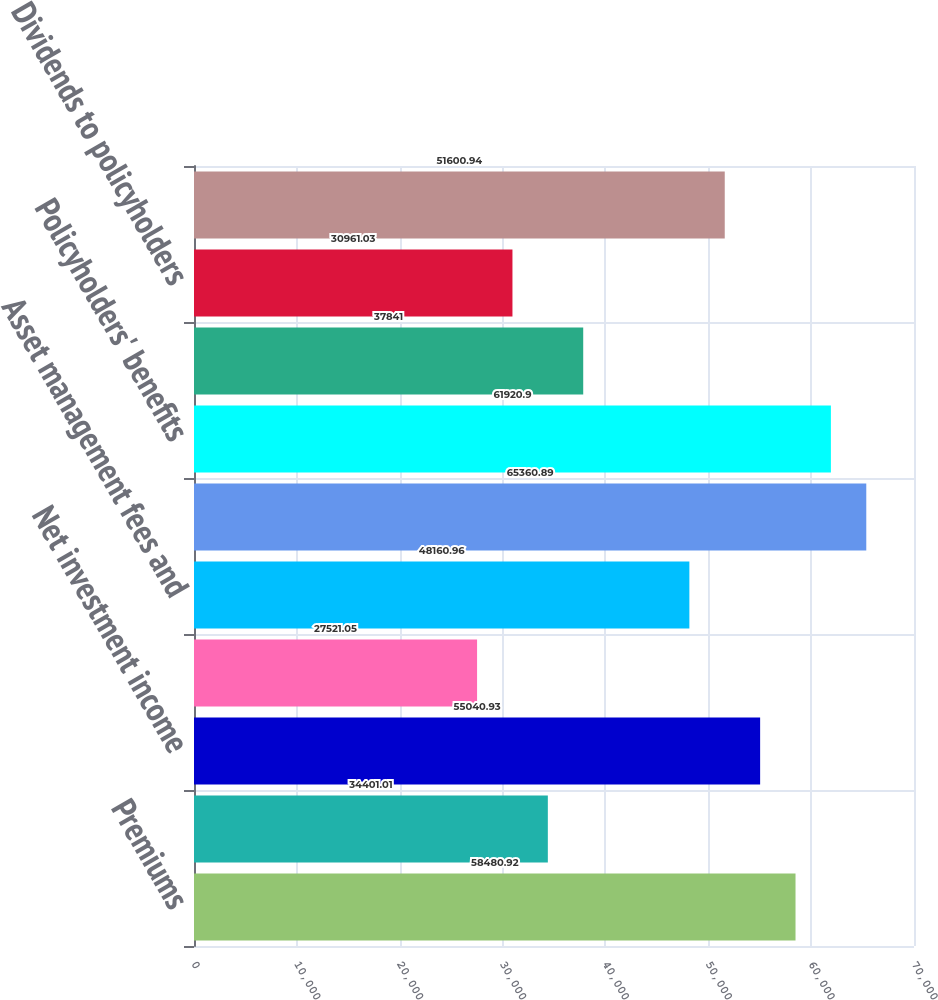<chart> <loc_0><loc_0><loc_500><loc_500><bar_chart><fcel>Premiums<fcel>Policy charges and fee income<fcel>Net investment income<fcel>Realized investment gains<fcel>Asset management fees and<fcel>Total revenues<fcel>Policyholders' benefits<fcel>Interest credited to<fcel>Dividends to policyholders<fcel>General and administrative<nl><fcel>58480.9<fcel>34401<fcel>55040.9<fcel>27521<fcel>48161<fcel>65360.9<fcel>61920.9<fcel>37841<fcel>30961<fcel>51600.9<nl></chart> 